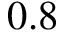<formula> <loc_0><loc_0><loc_500><loc_500>0 . 8</formula> 